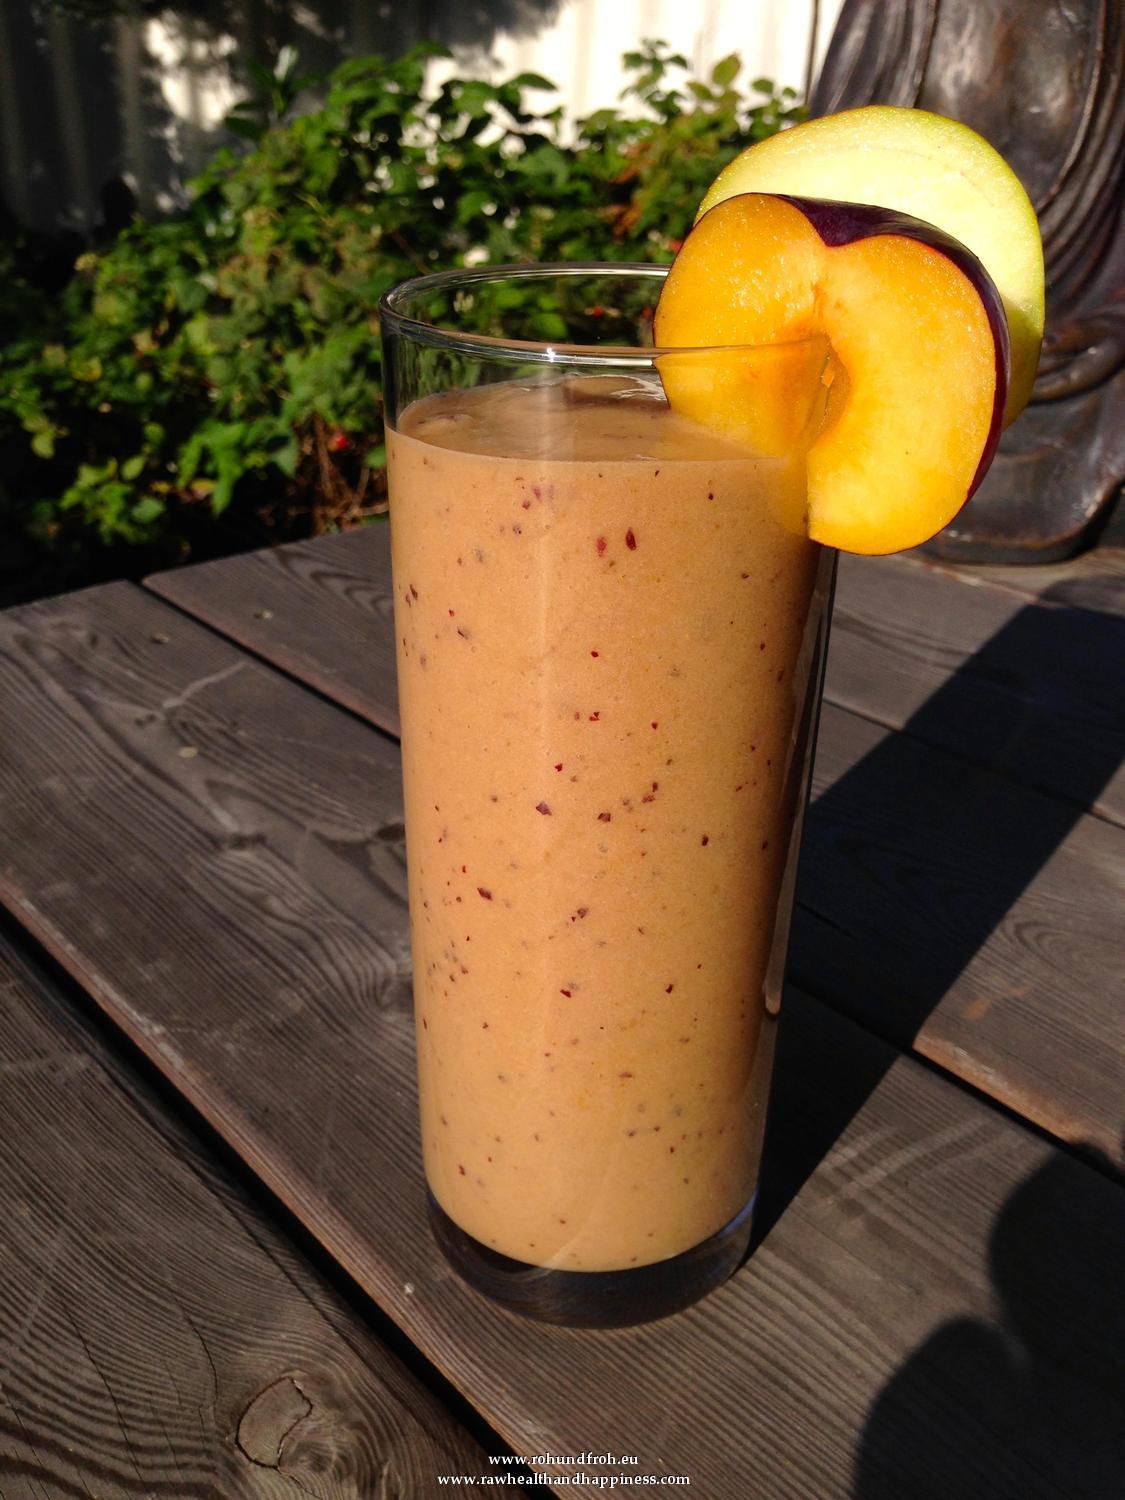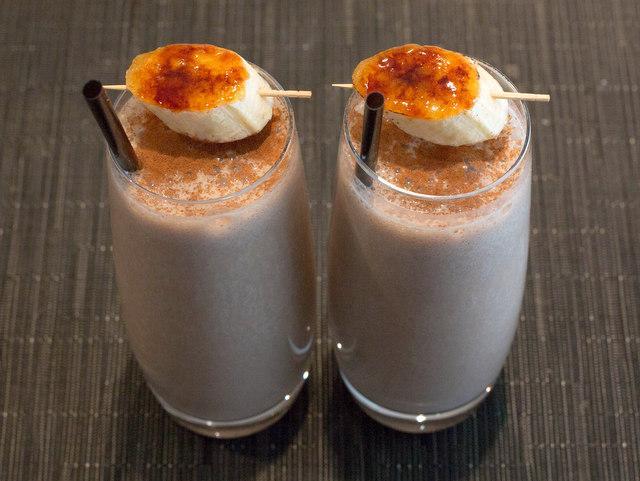The first image is the image on the left, the second image is the image on the right. Considering the images on both sides, is "There is green juice in one of the images." valid? Answer yes or no. No. The first image is the image on the left, the second image is the image on the right. Examine the images to the left and right. Is the description "Each image includes one garnished glass of creamy beverage but no straws, and one of the glasses pictured has a leafy green garnish." accurate? Answer yes or no. No. 